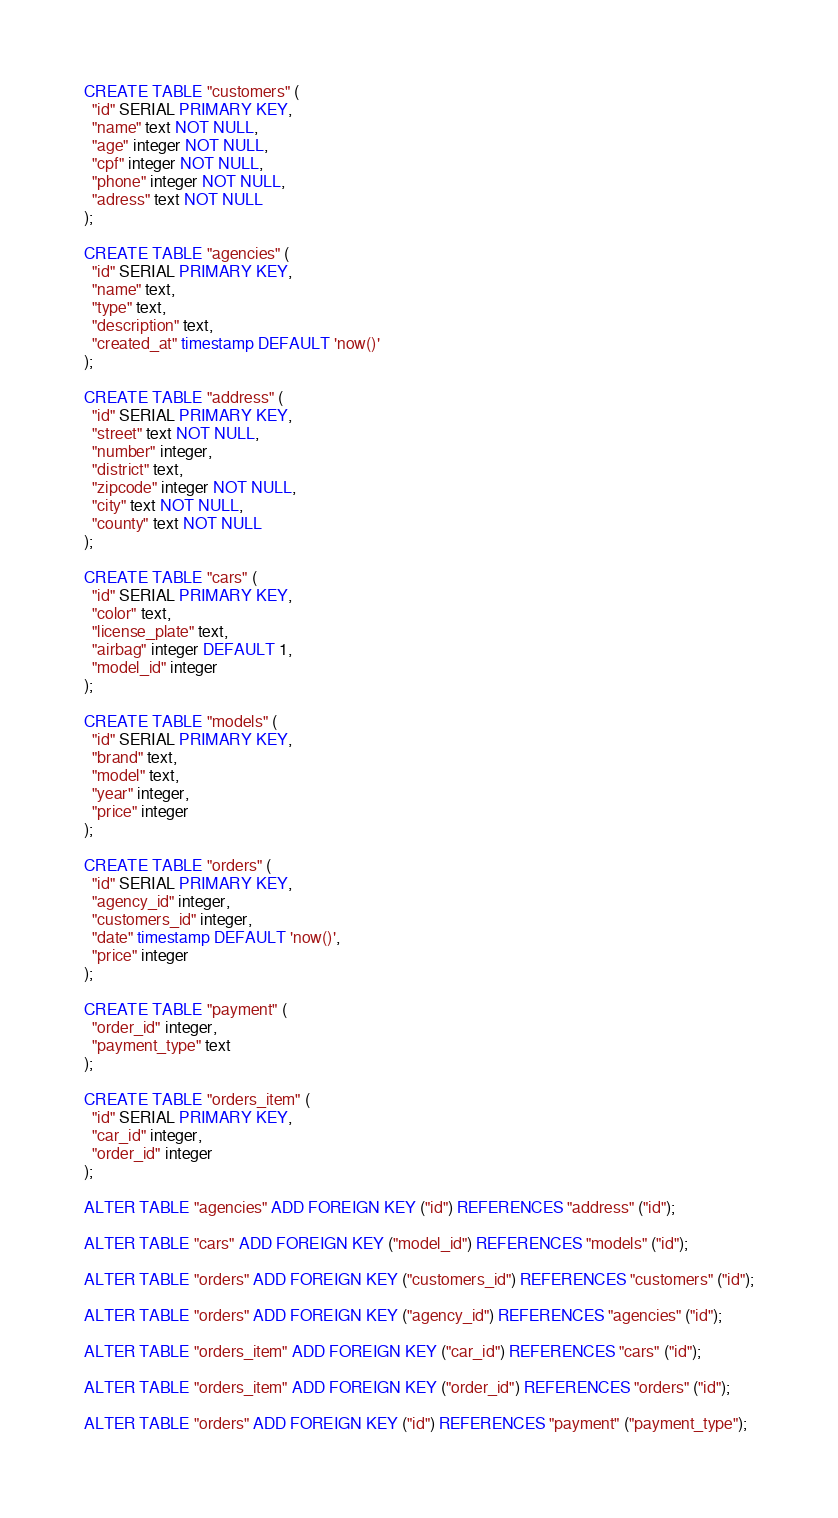<code> <loc_0><loc_0><loc_500><loc_500><_SQL_>CREATE TABLE "customers" (
  "id" SERIAL PRIMARY KEY,
  "name" text NOT NULL,
  "age" integer NOT NULL,
  "cpf" integer NOT NULL,
  "phone" integer NOT NULL,
  "adress" text NOT NULL
);

CREATE TABLE "agencies" (
  "id" SERIAL PRIMARY KEY,
  "name" text,
  "type" text,
  "description" text,
  "created_at" timestamp DEFAULT 'now()'
);

CREATE TABLE "address" (
  "id" SERIAL PRIMARY KEY,
  "street" text NOT NULL,
  "number" integer,
  "district" text,
  "zipcode" integer NOT NULL,
  "city" text NOT NULL,
  "county" text NOT NULL
);

CREATE TABLE "cars" (
  "id" SERIAL PRIMARY KEY,
  "color" text,
  "license_plate" text,
  "airbag" integer DEFAULT 1,
  "model_id" integer
);

CREATE TABLE "models" (
  "id" SERIAL PRIMARY KEY,
  "brand" text,
  "model" text,
  "year" integer,
  "price" integer
);

CREATE TABLE "orders" (
  "id" SERIAL PRIMARY KEY,
  "agency_id" integer,
  "customers_id" integer,
  "date" timestamp DEFAULT 'now()',
  "price" integer
);

CREATE TABLE "payment" (
  "order_id" integer,
  "payment_type" text
);

CREATE TABLE "orders_item" (
  "id" SERIAL PRIMARY KEY,
  "car_id" integer,
  "order_id" integer
);

ALTER TABLE "agencies" ADD FOREIGN KEY ("id") REFERENCES "address" ("id");

ALTER TABLE "cars" ADD FOREIGN KEY ("model_id") REFERENCES "models" ("id");

ALTER TABLE "orders" ADD FOREIGN KEY ("customers_id") REFERENCES "customers" ("id");

ALTER TABLE "orders" ADD FOREIGN KEY ("agency_id") REFERENCES "agencies" ("id");

ALTER TABLE "orders_item" ADD FOREIGN KEY ("car_id") REFERENCES "cars" ("id");

ALTER TABLE "orders_item" ADD FOREIGN KEY ("order_id") REFERENCES "orders" ("id");

ALTER TABLE "orders" ADD FOREIGN KEY ("id") REFERENCES "payment" ("payment_type");
</code> 